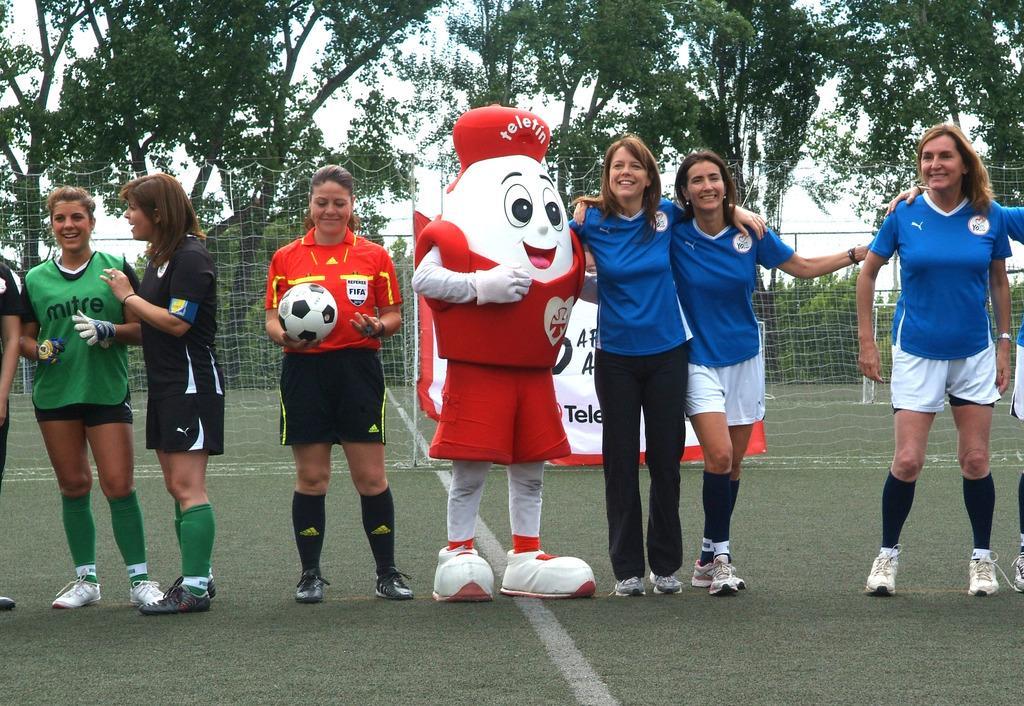Could you give a brief overview of what you see in this image? As we can see in the image there are trees, fence, few people standing over here. 